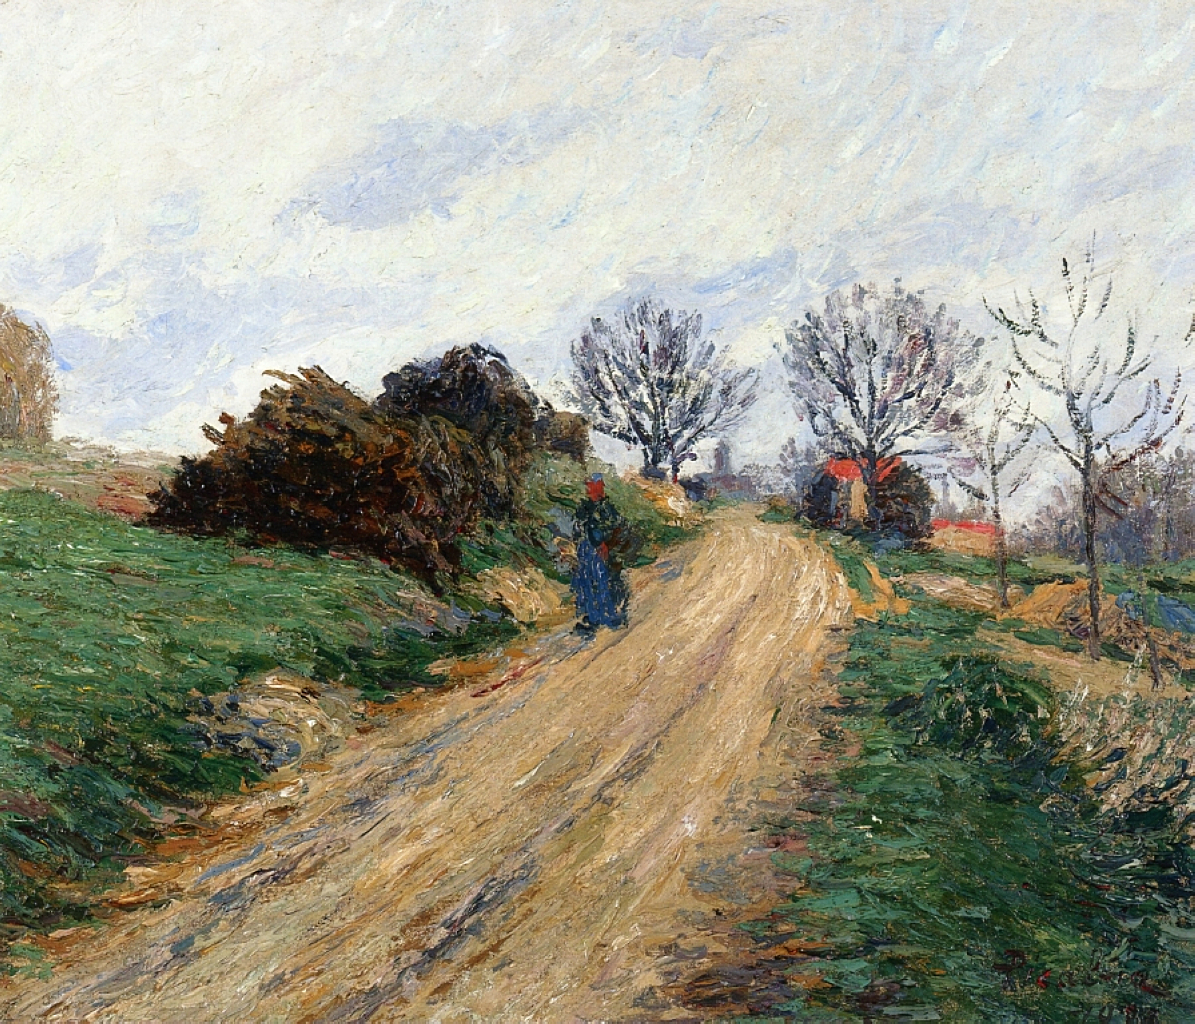Explain the visual content of the image in great detail. The image is a beautiful representation of an impressionist painting, likely by an artist such as Claude Monet or Camille Pissarro. The scene captures a rural landscape, featuring a winding dirt road that invites the viewer into the painting. This road is flanked by lush greenery with tall grasses and bushes, guiding the viewer’s eye into the distance where a few quaint houses are tucked away, adding a hint of human presence.

On the left side of the road, a large, dense bush breaks the uniformity of the flat terrain, while the right side is marked by smaller, more sparsely placed trees and plants. The trees are leafless, possibly indicating the painting depicts a season like autumn or early spring. These elements create a sense of depth and perspective, drawing attention to the center of the image.

The sky above is expansive, with soft, wispy clouds spread across a pale blue backdrop, contributing to the serene and calm atmosphere of the scene. The color palette used is dominated by muted tones of greens and browns, accented occasionally by brighter pops of red and orange, which add vibrancy and life. The use of these colors in combination with the loose, visible brush strokes—hallmarks of the impressionist style—imbues the painting with a sense of movement and light.

The brushwork is deliberately loose and expressive, capturing the fleeting effects of sunlight on the landscape, rather than detailing every element meticulously. This technique of focusing on light and color interplay exemplifies the impressionist focus on capturing a moment in time, as seen through the artist's perception. Overall, the painting is a testament to the impressionist genre, embodying not just the subject matter, but the very act of painting itself, rendering an emotive and evocative snapshot of rural life. 